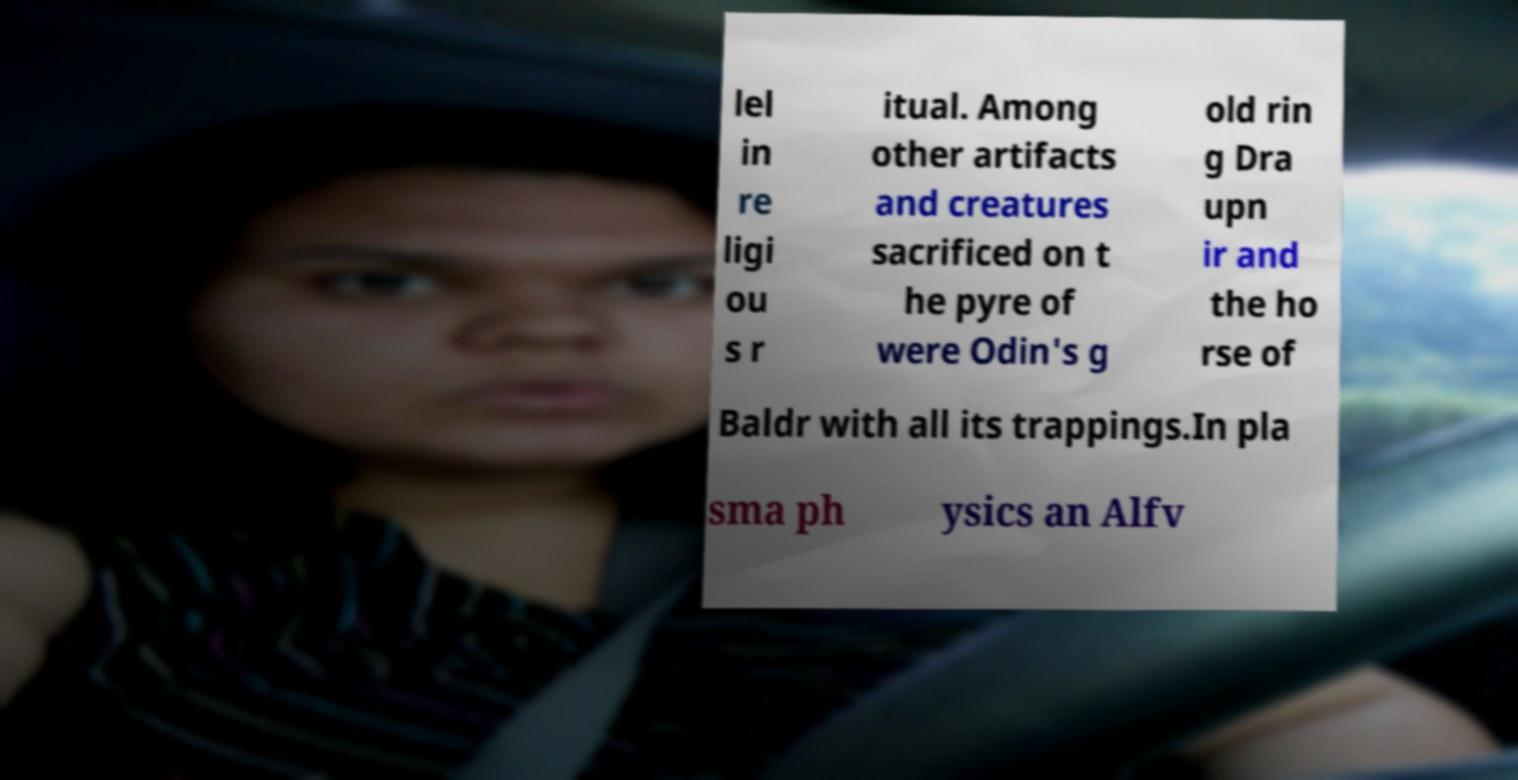Could you extract and type out the text from this image? lel in re ligi ou s r itual. Among other artifacts and creatures sacrificed on t he pyre of were Odin's g old rin g Dra upn ir and the ho rse of Baldr with all its trappings.In pla sma ph ysics an Alfv 